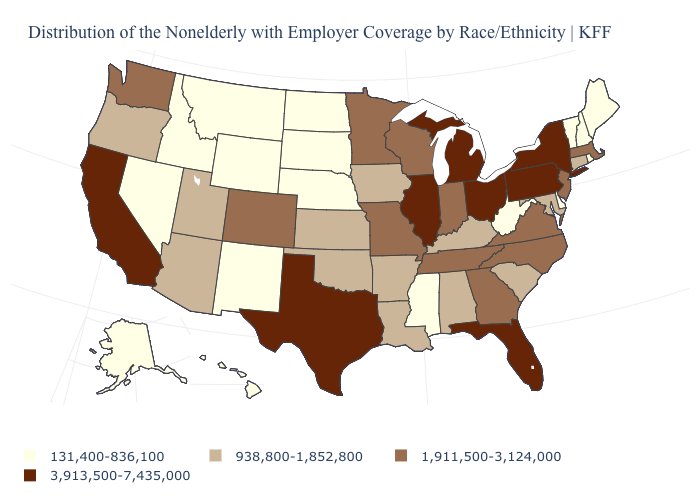Does Tennessee have the highest value in the USA?
Short answer required. No. How many symbols are there in the legend?
Give a very brief answer. 4. What is the lowest value in the USA?
Give a very brief answer. 131,400-836,100. Name the states that have a value in the range 131,400-836,100?
Write a very short answer. Alaska, Delaware, Hawaii, Idaho, Maine, Mississippi, Montana, Nebraska, Nevada, New Hampshire, New Mexico, North Dakota, Rhode Island, South Dakota, Vermont, West Virginia, Wyoming. Name the states that have a value in the range 131,400-836,100?
Short answer required. Alaska, Delaware, Hawaii, Idaho, Maine, Mississippi, Montana, Nebraska, Nevada, New Hampshire, New Mexico, North Dakota, Rhode Island, South Dakota, Vermont, West Virginia, Wyoming. How many symbols are there in the legend?
Concise answer only. 4. What is the value of Mississippi?
Be succinct. 131,400-836,100. How many symbols are there in the legend?
Answer briefly. 4. What is the value of Maryland?
Quick response, please. 938,800-1,852,800. Does Oregon have the lowest value in the West?
Give a very brief answer. No. Which states hav the highest value in the South?
Be succinct. Florida, Texas. Which states have the lowest value in the USA?
Concise answer only. Alaska, Delaware, Hawaii, Idaho, Maine, Mississippi, Montana, Nebraska, Nevada, New Hampshire, New Mexico, North Dakota, Rhode Island, South Dakota, Vermont, West Virginia, Wyoming. Which states have the lowest value in the USA?
Write a very short answer. Alaska, Delaware, Hawaii, Idaho, Maine, Mississippi, Montana, Nebraska, Nevada, New Hampshire, New Mexico, North Dakota, Rhode Island, South Dakota, Vermont, West Virginia, Wyoming. Which states have the highest value in the USA?
Concise answer only. California, Florida, Illinois, Michigan, New York, Ohio, Pennsylvania, Texas. 